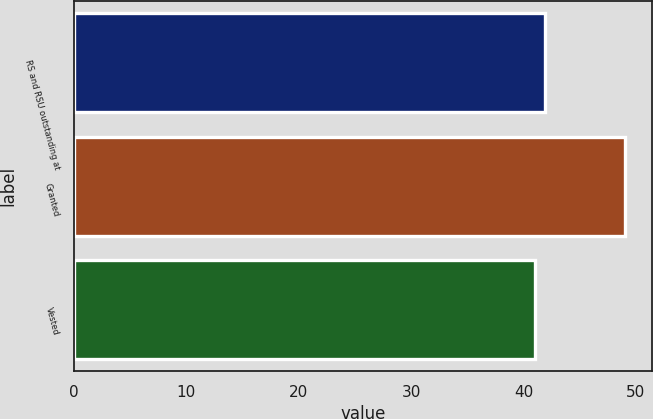Convert chart to OTSL. <chart><loc_0><loc_0><loc_500><loc_500><bar_chart><fcel>RS and RSU outstanding at<fcel>Granted<fcel>Vested<nl><fcel>41.9<fcel>49<fcel>41<nl></chart> 